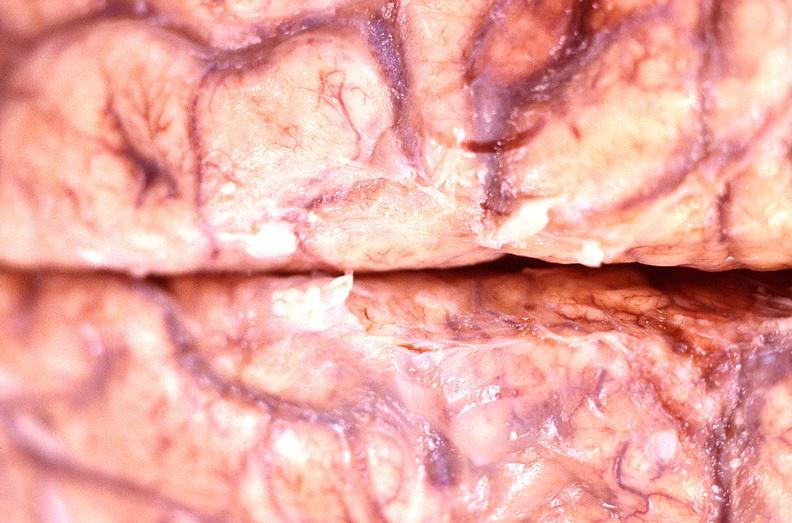does coronary artery show brain abscess?
Answer the question using a single word or phrase. No 